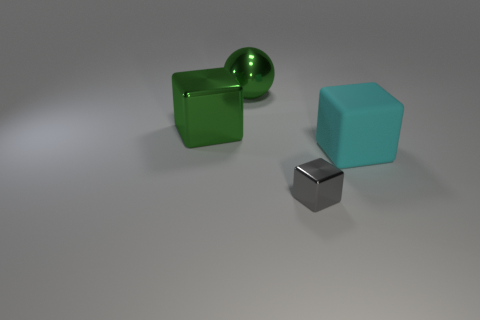Add 2 large cyan things. How many large cyan things exist? 3 Add 1 matte things. How many objects exist? 5 Subtract all gray blocks. How many blocks are left? 2 Subtract all large cyan matte blocks. How many blocks are left? 2 Subtract 0 purple cylinders. How many objects are left? 4 Subtract all blocks. How many objects are left? 1 Subtract 1 spheres. How many spheres are left? 0 Subtract all yellow spheres. Subtract all brown cubes. How many spheres are left? 1 Subtract all brown cylinders. How many gray cubes are left? 1 Subtract all small metallic things. Subtract all large rubber objects. How many objects are left? 2 